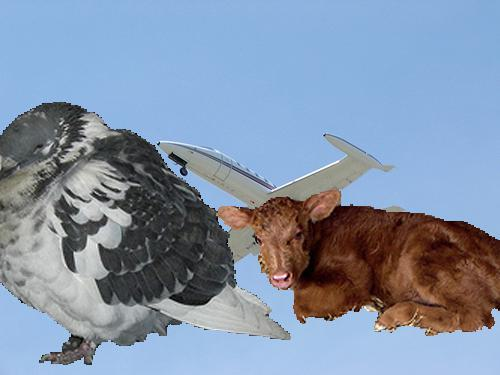How do the elements in this image relate to each other? In this image, the elements seem to juxtapose nature with the man-made: the organic form of the calf against the artificiality of the aeroplane. The pictured bird with an aeroplane's body might symbolize a fusion of the natural world with human technology. 